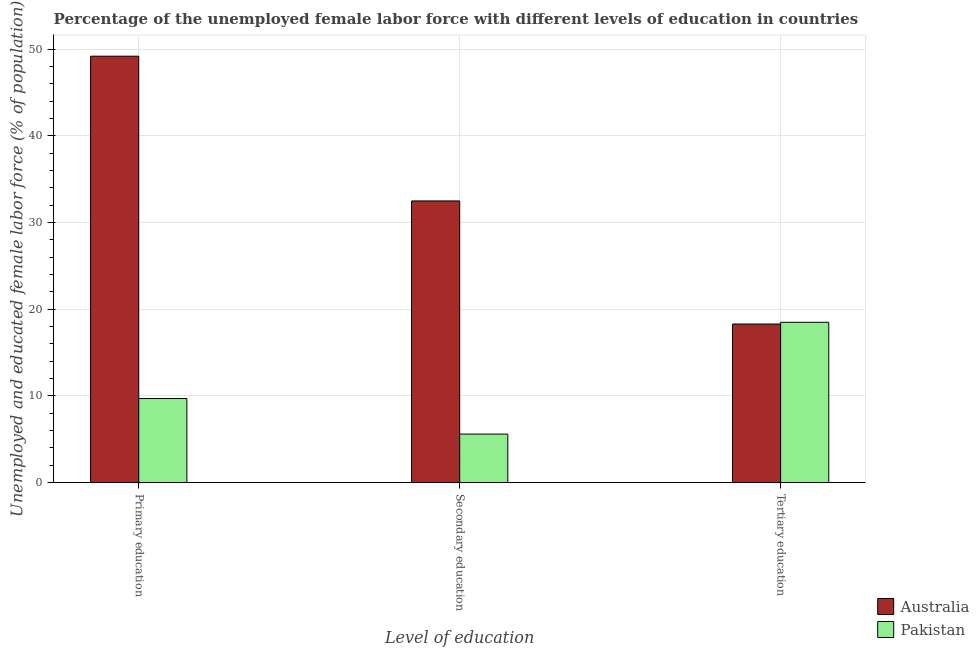How many different coloured bars are there?
Keep it short and to the point. 2. Are the number of bars per tick equal to the number of legend labels?
Your answer should be compact. Yes. How many bars are there on the 2nd tick from the left?
Ensure brevity in your answer.  2. What is the label of the 3rd group of bars from the left?
Your answer should be compact. Tertiary education. What is the percentage of female labor force who received primary education in Australia?
Your answer should be very brief. 49.2. Across all countries, what is the minimum percentage of female labor force who received primary education?
Offer a very short reply. 9.7. In which country was the percentage of female labor force who received primary education maximum?
Provide a succinct answer. Australia. In which country was the percentage of female labor force who received tertiary education minimum?
Ensure brevity in your answer.  Australia. What is the total percentage of female labor force who received tertiary education in the graph?
Give a very brief answer. 36.8. What is the difference between the percentage of female labor force who received secondary education in Pakistan and that in Australia?
Offer a very short reply. -26.9. What is the difference between the percentage of female labor force who received primary education in Australia and the percentage of female labor force who received secondary education in Pakistan?
Offer a very short reply. 43.6. What is the average percentage of female labor force who received secondary education per country?
Your answer should be very brief. 19.05. What is the difference between the percentage of female labor force who received secondary education and percentage of female labor force who received primary education in Pakistan?
Give a very brief answer. -4.1. In how many countries, is the percentage of female labor force who received tertiary education greater than 30 %?
Your answer should be very brief. 0. What is the ratio of the percentage of female labor force who received primary education in Australia to that in Pakistan?
Keep it short and to the point. 5.07. What is the difference between the highest and the second highest percentage of female labor force who received secondary education?
Provide a short and direct response. 26.9. What is the difference between the highest and the lowest percentage of female labor force who received secondary education?
Offer a very short reply. 26.9. In how many countries, is the percentage of female labor force who received primary education greater than the average percentage of female labor force who received primary education taken over all countries?
Provide a short and direct response. 1. Is the sum of the percentage of female labor force who received primary education in Australia and Pakistan greater than the maximum percentage of female labor force who received secondary education across all countries?
Your answer should be very brief. Yes. What does the 1st bar from the left in Primary education represents?
Make the answer very short. Australia. How many bars are there?
Provide a short and direct response. 6. Are all the bars in the graph horizontal?
Give a very brief answer. No. How many legend labels are there?
Offer a terse response. 2. How are the legend labels stacked?
Ensure brevity in your answer.  Vertical. What is the title of the graph?
Provide a short and direct response. Percentage of the unemployed female labor force with different levels of education in countries. Does "Bulgaria" appear as one of the legend labels in the graph?
Your answer should be compact. No. What is the label or title of the X-axis?
Provide a short and direct response. Level of education. What is the label or title of the Y-axis?
Keep it short and to the point. Unemployed and educated female labor force (% of population). What is the Unemployed and educated female labor force (% of population) of Australia in Primary education?
Keep it short and to the point. 49.2. What is the Unemployed and educated female labor force (% of population) in Pakistan in Primary education?
Offer a terse response. 9.7. What is the Unemployed and educated female labor force (% of population) in Australia in Secondary education?
Provide a short and direct response. 32.5. What is the Unemployed and educated female labor force (% of population) of Pakistan in Secondary education?
Make the answer very short. 5.6. What is the Unemployed and educated female labor force (% of population) in Australia in Tertiary education?
Keep it short and to the point. 18.3. What is the Unemployed and educated female labor force (% of population) in Pakistan in Tertiary education?
Ensure brevity in your answer.  18.5. Across all Level of education, what is the maximum Unemployed and educated female labor force (% of population) in Australia?
Make the answer very short. 49.2. Across all Level of education, what is the maximum Unemployed and educated female labor force (% of population) of Pakistan?
Your answer should be compact. 18.5. Across all Level of education, what is the minimum Unemployed and educated female labor force (% of population) of Australia?
Your response must be concise. 18.3. Across all Level of education, what is the minimum Unemployed and educated female labor force (% of population) in Pakistan?
Your response must be concise. 5.6. What is the total Unemployed and educated female labor force (% of population) of Pakistan in the graph?
Your answer should be compact. 33.8. What is the difference between the Unemployed and educated female labor force (% of population) of Pakistan in Primary education and that in Secondary education?
Provide a short and direct response. 4.1. What is the difference between the Unemployed and educated female labor force (% of population) in Australia in Primary education and that in Tertiary education?
Offer a very short reply. 30.9. What is the difference between the Unemployed and educated female labor force (% of population) in Australia in Primary education and the Unemployed and educated female labor force (% of population) in Pakistan in Secondary education?
Offer a terse response. 43.6. What is the difference between the Unemployed and educated female labor force (% of population) in Australia in Primary education and the Unemployed and educated female labor force (% of population) in Pakistan in Tertiary education?
Give a very brief answer. 30.7. What is the average Unemployed and educated female labor force (% of population) in Australia per Level of education?
Your answer should be compact. 33.33. What is the average Unemployed and educated female labor force (% of population) in Pakistan per Level of education?
Make the answer very short. 11.27. What is the difference between the Unemployed and educated female labor force (% of population) of Australia and Unemployed and educated female labor force (% of population) of Pakistan in Primary education?
Offer a very short reply. 39.5. What is the difference between the Unemployed and educated female labor force (% of population) of Australia and Unemployed and educated female labor force (% of population) of Pakistan in Secondary education?
Offer a terse response. 26.9. What is the difference between the Unemployed and educated female labor force (% of population) of Australia and Unemployed and educated female labor force (% of population) of Pakistan in Tertiary education?
Ensure brevity in your answer.  -0.2. What is the ratio of the Unemployed and educated female labor force (% of population) in Australia in Primary education to that in Secondary education?
Offer a very short reply. 1.51. What is the ratio of the Unemployed and educated female labor force (% of population) in Pakistan in Primary education to that in Secondary education?
Give a very brief answer. 1.73. What is the ratio of the Unemployed and educated female labor force (% of population) in Australia in Primary education to that in Tertiary education?
Provide a short and direct response. 2.69. What is the ratio of the Unemployed and educated female labor force (% of population) in Pakistan in Primary education to that in Tertiary education?
Provide a short and direct response. 0.52. What is the ratio of the Unemployed and educated female labor force (% of population) in Australia in Secondary education to that in Tertiary education?
Offer a very short reply. 1.78. What is the ratio of the Unemployed and educated female labor force (% of population) in Pakistan in Secondary education to that in Tertiary education?
Your answer should be compact. 0.3. What is the difference between the highest and the second highest Unemployed and educated female labor force (% of population) in Australia?
Ensure brevity in your answer.  16.7. What is the difference between the highest and the second highest Unemployed and educated female labor force (% of population) in Pakistan?
Provide a short and direct response. 8.8. What is the difference between the highest and the lowest Unemployed and educated female labor force (% of population) of Australia?
Offer a terse response. 30.9. 